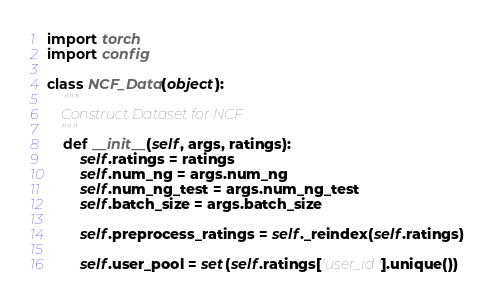<code> <loc_0><loc_0><loc_500><loc_500><_Python_>import torch
import config 

class NCF_Data(object):
	"""
	Construct Dataset for NCF
	"""
	def __init__(self, args, ratings):
		self.ratings = ratings
		self.num_ng = args.num_ng
		self.num_ng_test = args.num_ng_test
		self.batch_size = args.batch_size

		self.preprocess_ratings = self._reindex(self.ratings)

		self.user_pool = set(self.ratings['user_id'].unique())</code> 